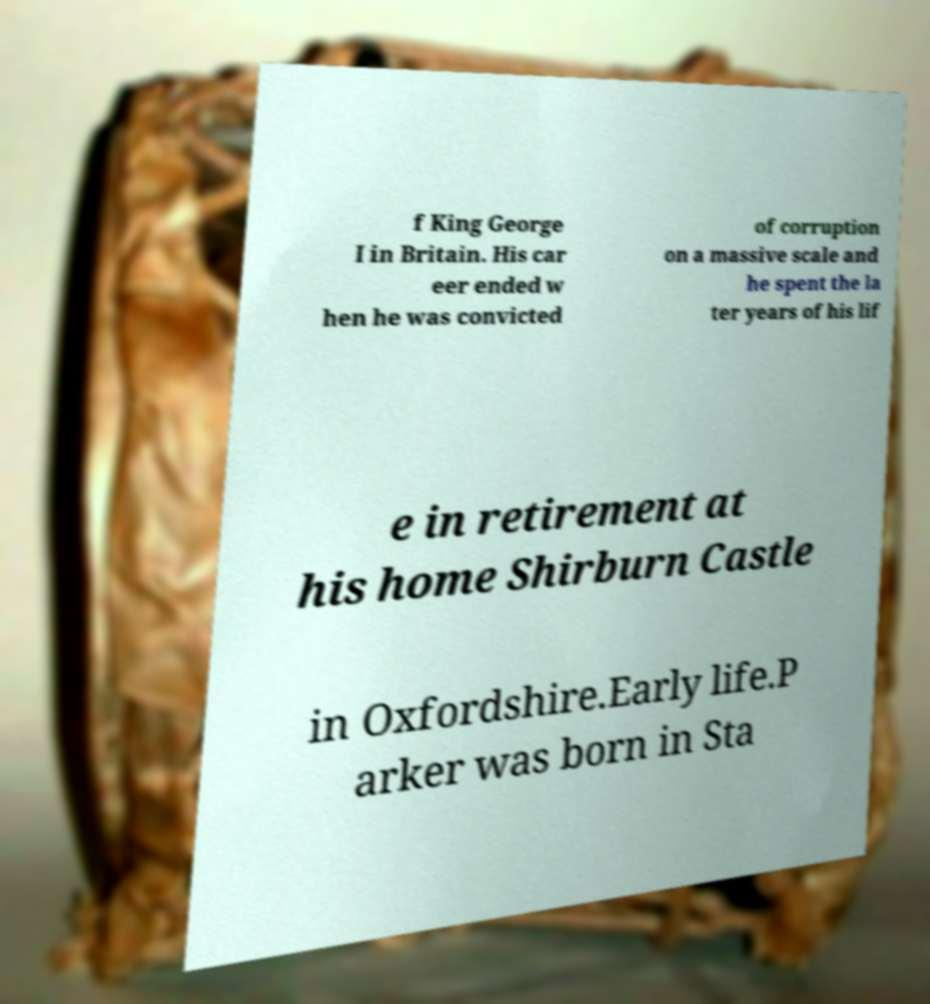I need the written content from this picture converted into text. Can you do that? f King George I in Britain. His car eer ended w hen he was convicted of corruption on a massive scale and he spent the la ter years of his lif e in retirement at his home Shirburn Castle in Oxfordshire.Early life.P arker was born in Sta 